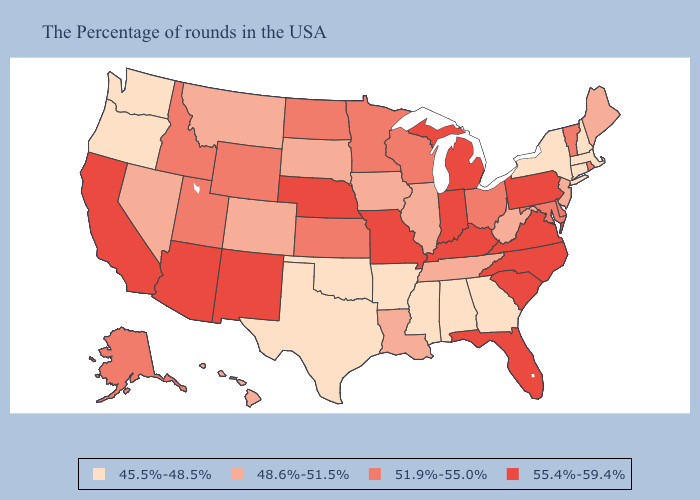What is the lowest value in states that border Louisiana?
Give a very brief answer. 45.5%-48.5%. What is the value of Tennessee?
Concise answer only. 48.6%-51.5%. Does Iowa have the highest value in the MidWest?
Answer briefly. No. Name the states that have a value in the range 55.4%-59.4%?
Keep it brief. Pennsylvania, Virginia, North Carolina, South Carolina, Florida, Michigan, Kentucky, Indiana, Missouri, Nebraska, New Mexico, Arizona, California. What is the lowest value in the USA?
Be succinct. 45.5%-48.5%. Name the states that have a value in the range 51.9%-55.0%?
Give a very brief answer. Rhode Island, Vermont, Delaware, Maryland, Ohio, Wisconsin, Minnesota, Kansas, North Dakota, Wyoming, Utah, Idaho, Alaska. What is the value of Nevada?
Quick response, please. 48.6%-51.5%. Name the states that have a value in the range 48.6%-51.5%?
Keep it brief. Maine, New Jersey, West Virginia, Tennessee, Illinois, Louisiana, Iowa, South Dakota, Colorado, Montana, Nevada, Hawaii. Among the states that border Delaware , does Pennsylvania have the lowest value?
Keep it brief. No. Name the states that have a value in the range 55.4%-59.4%?
Quick response, please. Pennsylvania, Virginia, North Carolina, South Carolina, Florida, Michigan, Kentucky, Indiana, Missouri, Nebraska, New Mexico, Arizona, California. Name the states that have a value in the range 45.5%-48.5%?
Keep it brief. Massachusetts, New Hampshire, Connecticut, New York, Georgia, Alabama, Mississippi, Arkansas, Oklahoma, Texas, Washington, Oregon. Name the states that have a value in the range 48.6%-51.5%?
Short answer required. Maine, New Jersey, West Virginia, Tennessee, Illinois, Louisiana, Iowa, South Dakota, Colorado, Montana, Nevada, Hawaii. Which states hav the highest value in the MidWest?
Be succinct. Michigan, Indiana, Missouri, Nebraska. Does the first symbol in the legend represent the smallest category?
Write a very short answer. Yes. Which states have the lowest value in the MidWest?
Short answer required. Illinois, Iowa, South Dakota. 